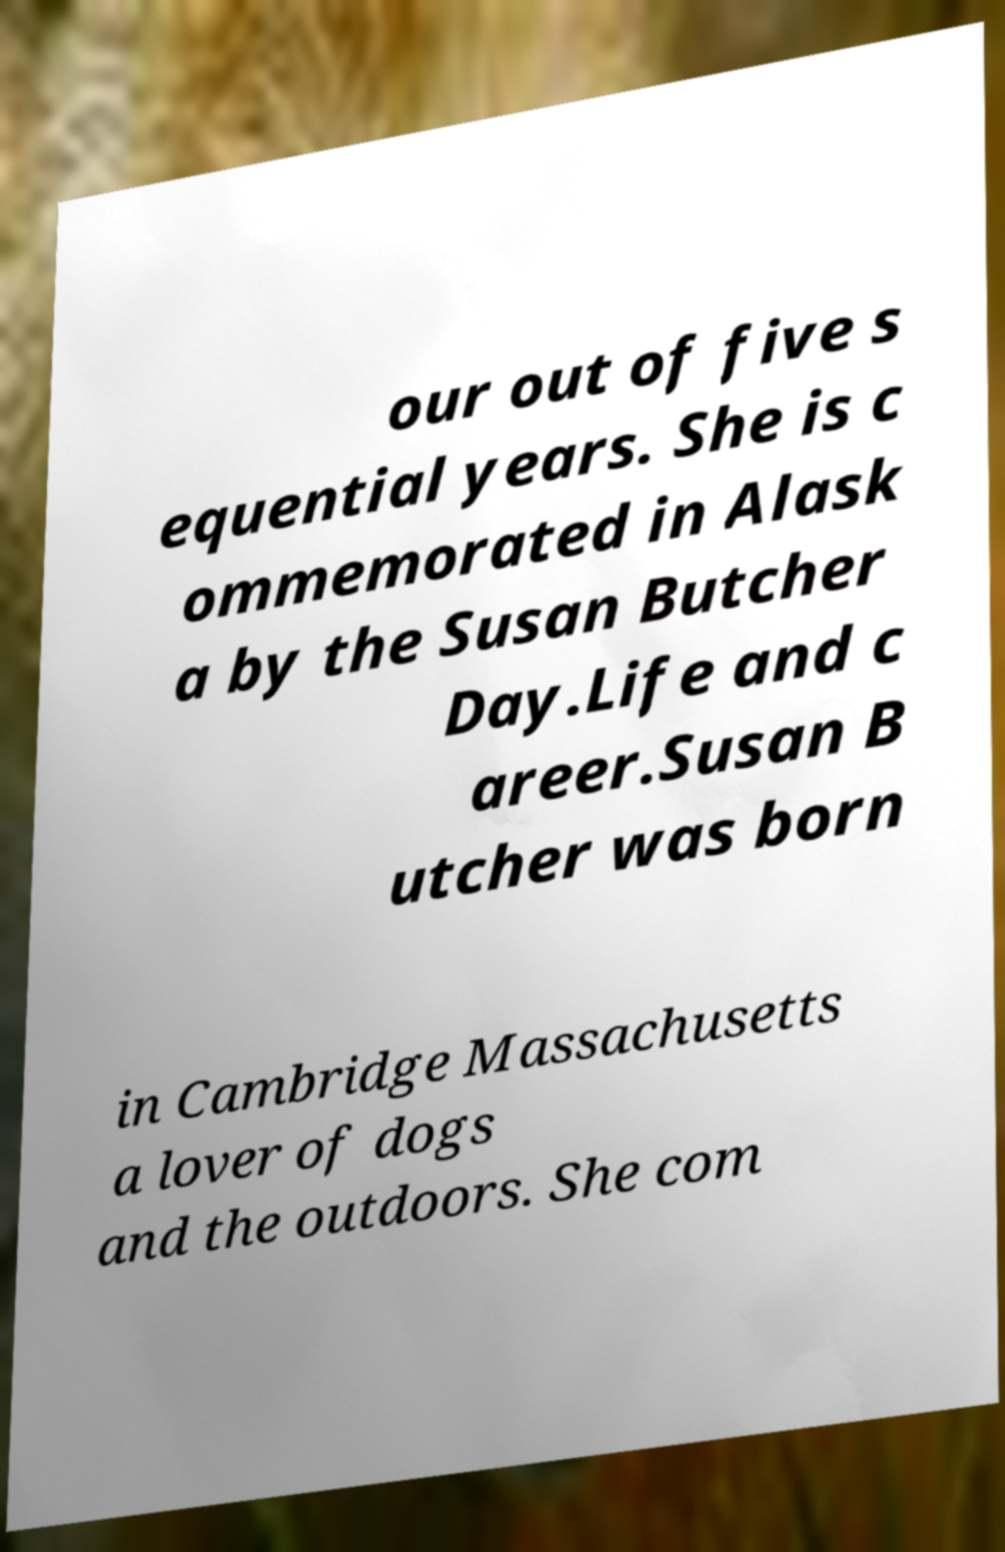Can you read and provide the text displayed in the image?This photo seems to have some interesting text. Can you extract and type it out for me? our out of five s equential years. She is c ommemorated in Alask a by the Susan Butcher Day.Life and c areer.Susan B utcher was born in Cambridge Massachusetts a lover of dogs and the outdoors. She com 